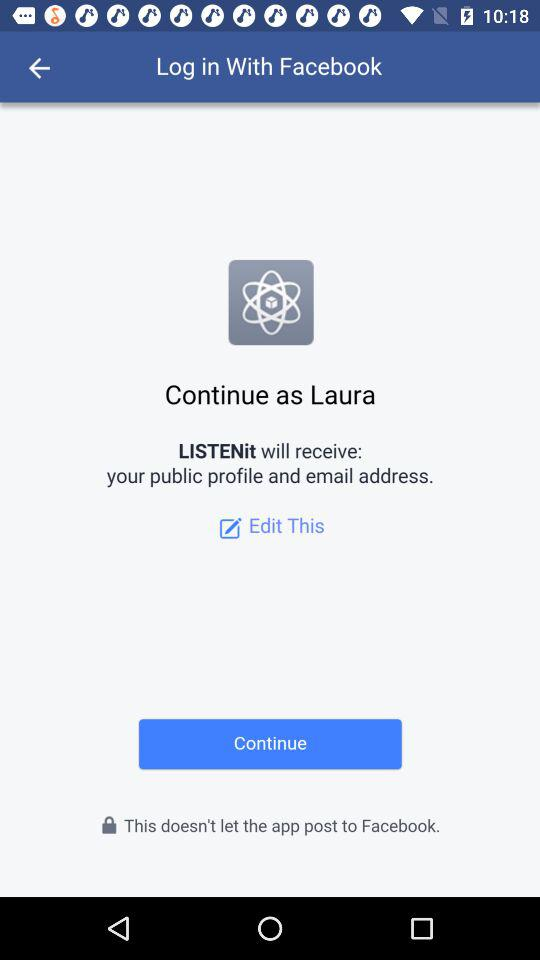What is the name of the user? The name of the user is Laura. 